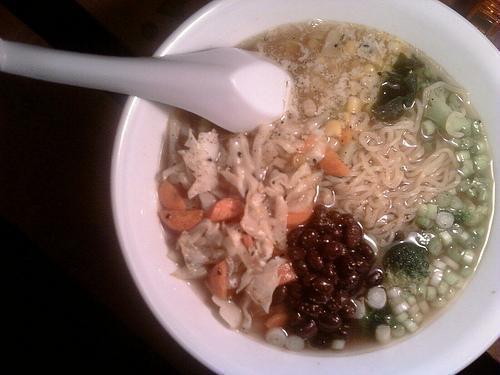How many bowls are there?
Give a very brief answer. 1. 